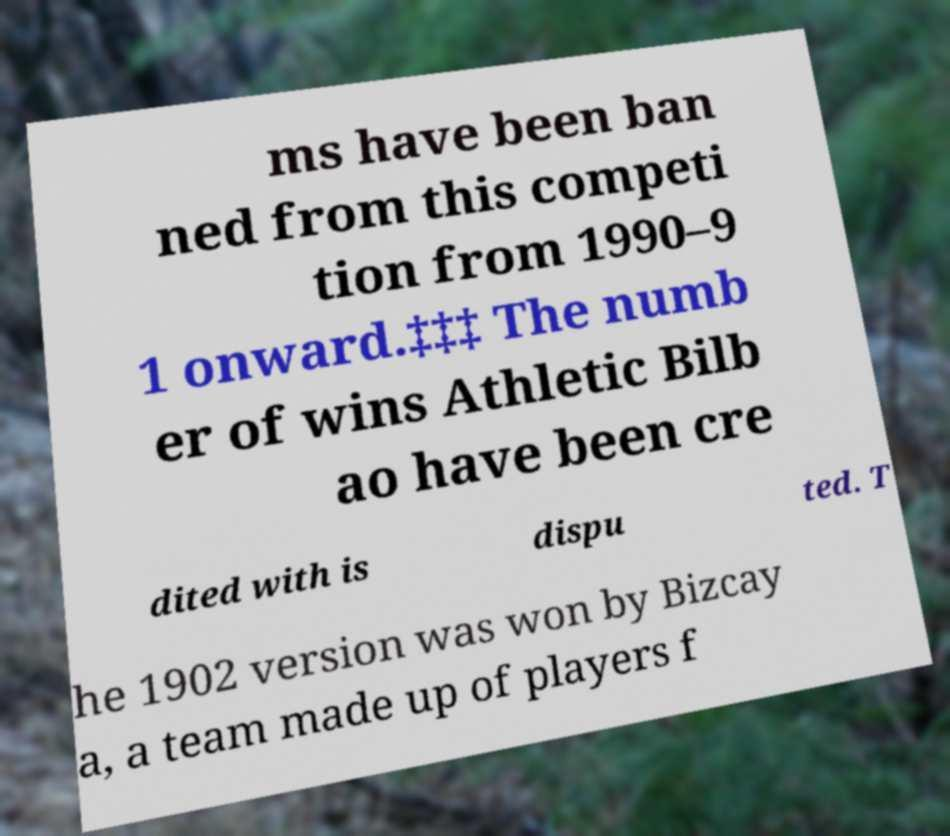Please read and relay the text visible in this image. What does it say? ms have been ban ned from this competi tion from 1990–9 1 onward.‡‡‡ The numb er of wins Athletic Bilb ao have been cre dited with is dispu ted. T he 1902 version was won by Bizcay a, a team made up of players f 